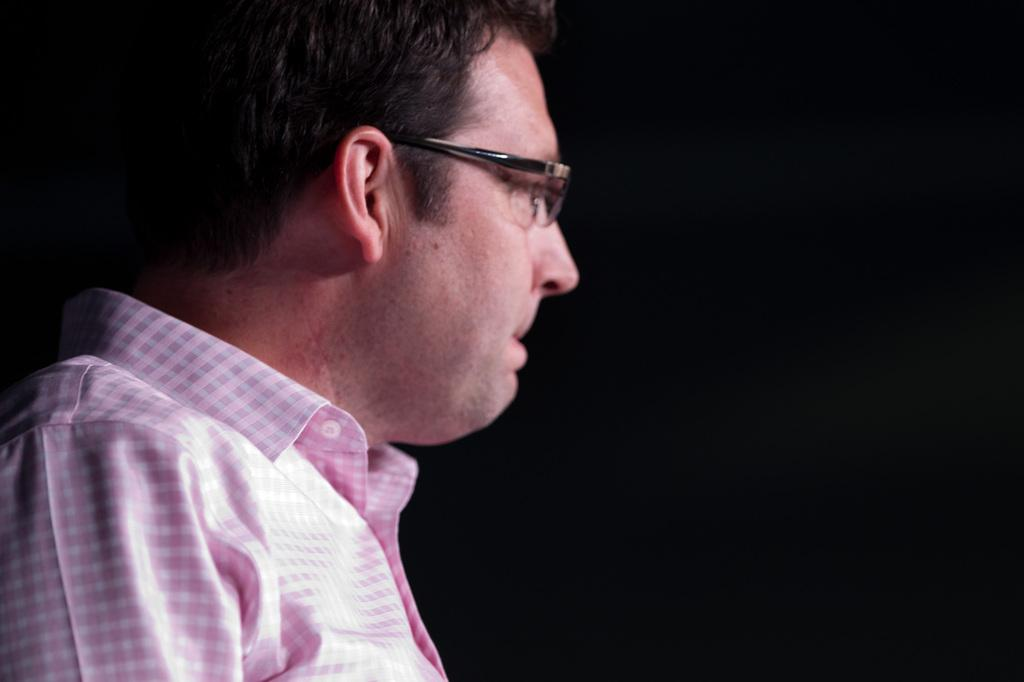What can be seen in the image? There is a person in the image. Can you describe the person's appearance? The person is wearing spectacles. What is the person doing in the image? The person is watching something. How would you describe the background of the image? The background of the image is dark in color. What type of produce can be seen in the image? There is no produce present in the image. How many clocks are visible in the image? There are no clocks visible in the image. 